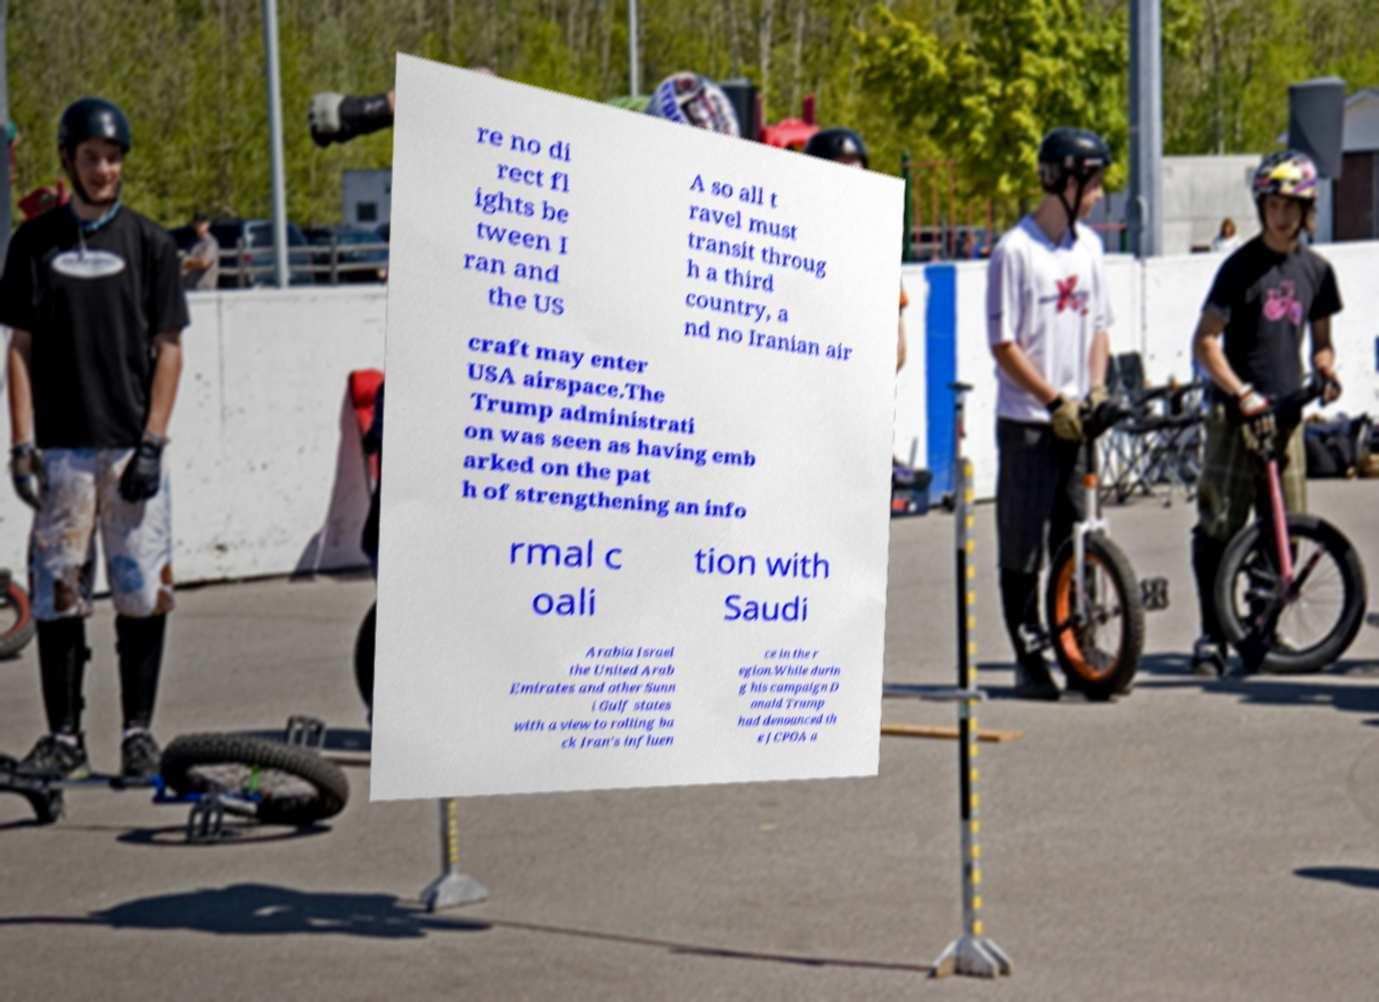For documentation purposes, I need the text within this image transcribed. Could you provide that? re no di rect fl ights be tween I ran and the US A so all t ravel must transit throug h a third country, a nd no Iranian air craft may enter USA airspace.The Trump administrati on was seen as having emb arked on the pat h of strengthening an info rmal c oali tion with Saudi Arabia Israel the United Arab Emirates and other Sunn i Gulf states with a view to rolling ba ck Iran's influen ce in the r egion.While durin g his campaign D onald Trump had denounced th e JCPOA a 